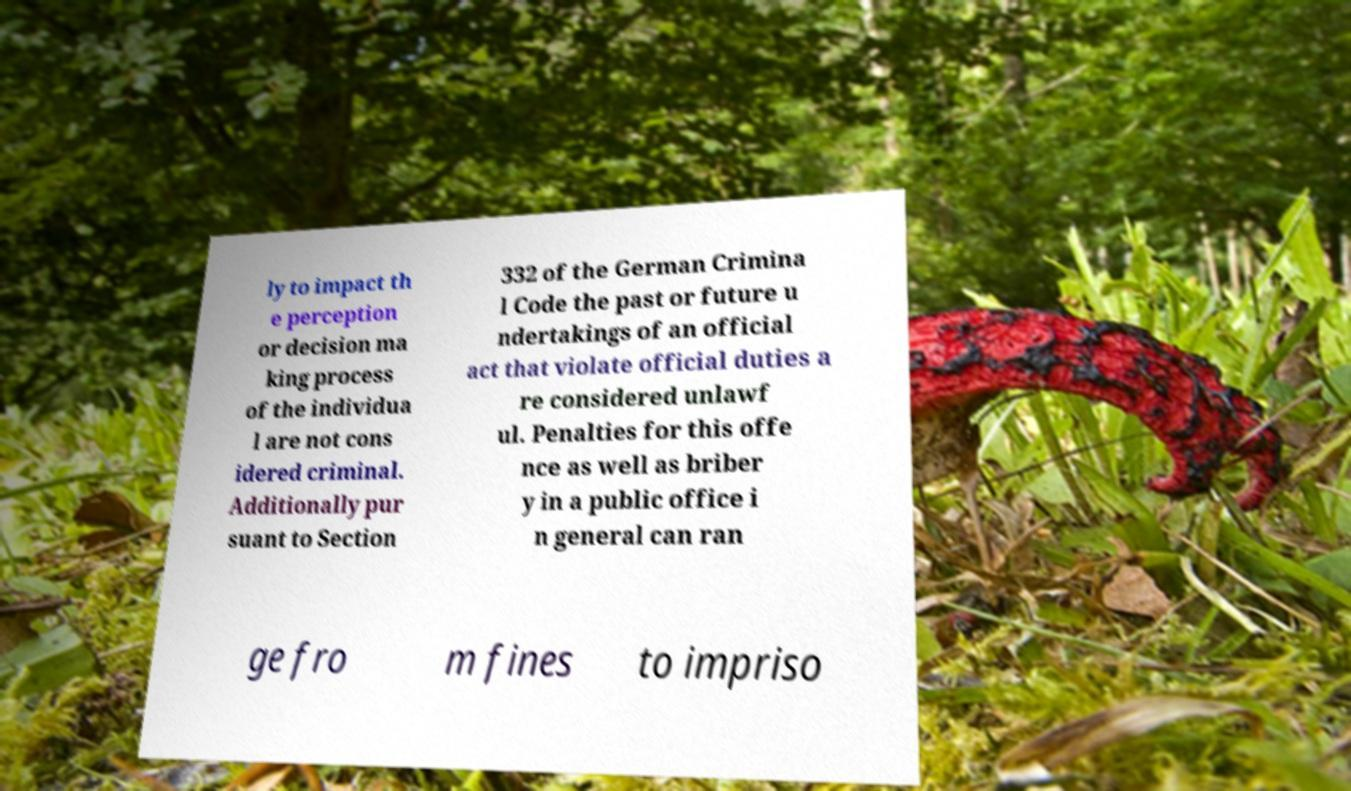What messages or text are displayed in this image? I need them in a readable, typed format. ly to impact th e perception or decision ma king process of the individua l are not cons idered criminal. Additionally pur suant to Section 332 of the German Crimina l Code the past or future u ndertakings of an official act that violate official duties a re considered unlawf ul. Penalties for this offe nce as well as briber y in a public office i n general can ran ge fro m fines to impriso 